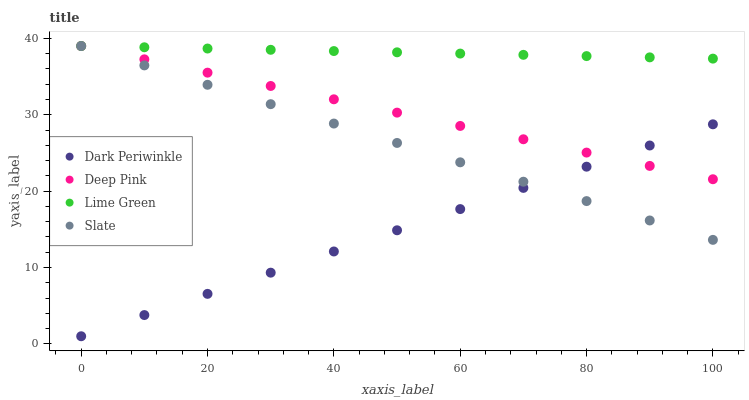Does Dark Periwinkle have the minimum area under the curve?
Answer yes or no. Yes. Does Lime Green have the maximum area under the curve?
Answer yes or no. Yes. Does Deep Pink have the minimum area under the curve?
Answer yes or no. No. Does Deep Pink have the maximum area under the curve?
Answer yes or no. No. Is Lime Green the smoothest?
Answer yes or no. Yes. Is Slate the roughest?
Answer yes or no. Yes. Is Deep Pink the smoothest?
Answer yes or no. No. Is Deep Pink the roughest?
Answer yes or no. No. Does Dark Periwinkle have the lowest value?
Answer yes or no. Yes. Does Deep Pink have the lowest value?
Answer yes or no. No. Does Lime Green have the highest value?
Answer yes or no. Yes. Does Dark Periwinkle have the highest value?
Answer yes or no. No. Is Dark Periwinkle less than Lime Green?
Answer yes or no. Yes. Is Lime Green greater than Dark Periwinkle?
Answer yes or no. Yes. Does Lime Green intersect Deep Pink?
Answer yes or no. Yes. Is Lime Green less than Deep Pink?
Answer yes or no. No. Is Lime Green greater than Deep Pink?
Answer yes or no. No. Does Dark Periwinkle intersect Lime Green?
Answer yes or no. No. 